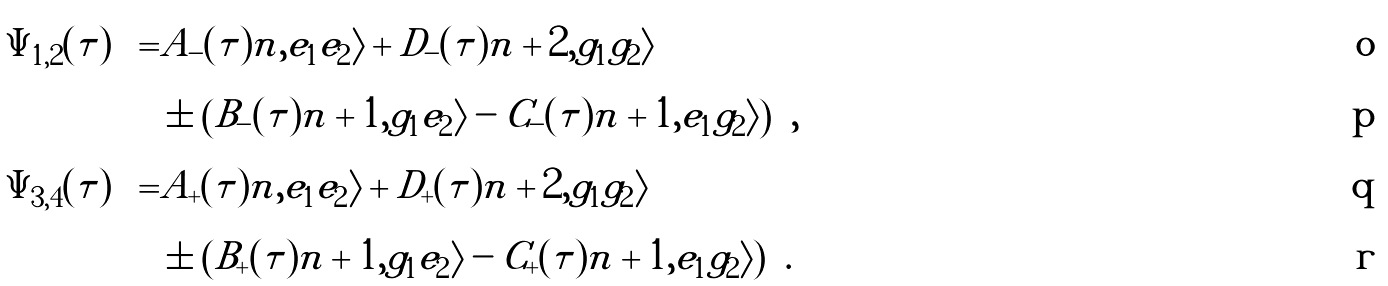Convert formula to latex. <formula><loc_0><loc_0><loc_500><loc_500>\left | \Psi _ { 1 , 2 } ( \tau ) \right \rangle = & A _ { - } ( \tau ) | n , e _ { 1 } e _ { 2 } \rangle + D _ { - } ( \tau ) | n + 2 , g _ { 1 } g _ { 2 } \rangle \\ & \pm \left ( B _ { - } ( \tau ) | n + 1 , g _ { 1 } e _ { 2 } \rangle - C _ { - } ( \tau ) | n + 1 , e _ { 1 } g _ { 2 } \rangle \right ) , \\ \left | \Psi _ { 3 , 4 } ( \tau ) \right \rangle = & A _ { + } ( \tau ) | n , e _ { 1 } e _ { 2 } \rangle + D _ { + } ( \tau ) | n + 2 , g _ { 1 } g _ { 2 } \rangle \\ & \pm \left ( B _ { + } ( \tau ) | n + 1 , g _ { 1 } e _ { 2 } \rangle - C _ { + } ( \tau ) | n + 1 , e _ { 1 } g _ { 2 } \rangle \right ) .</formula> 